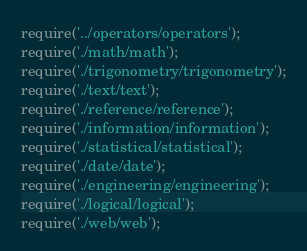Convert code to text. <code><loc_0><loc_0><loc_500><loc_500><_JavaScript_>require('../operators/operators');
require('./math/math');
require('./trigonometry/trigonometry');
require('./text/text');
require('./reference/reference');
require('./information/information');
require('./statistical/statistical');
require('./date/date');
require('./engineering/engineering');
require('./logical/logical');
require('./web/web');
</code> 